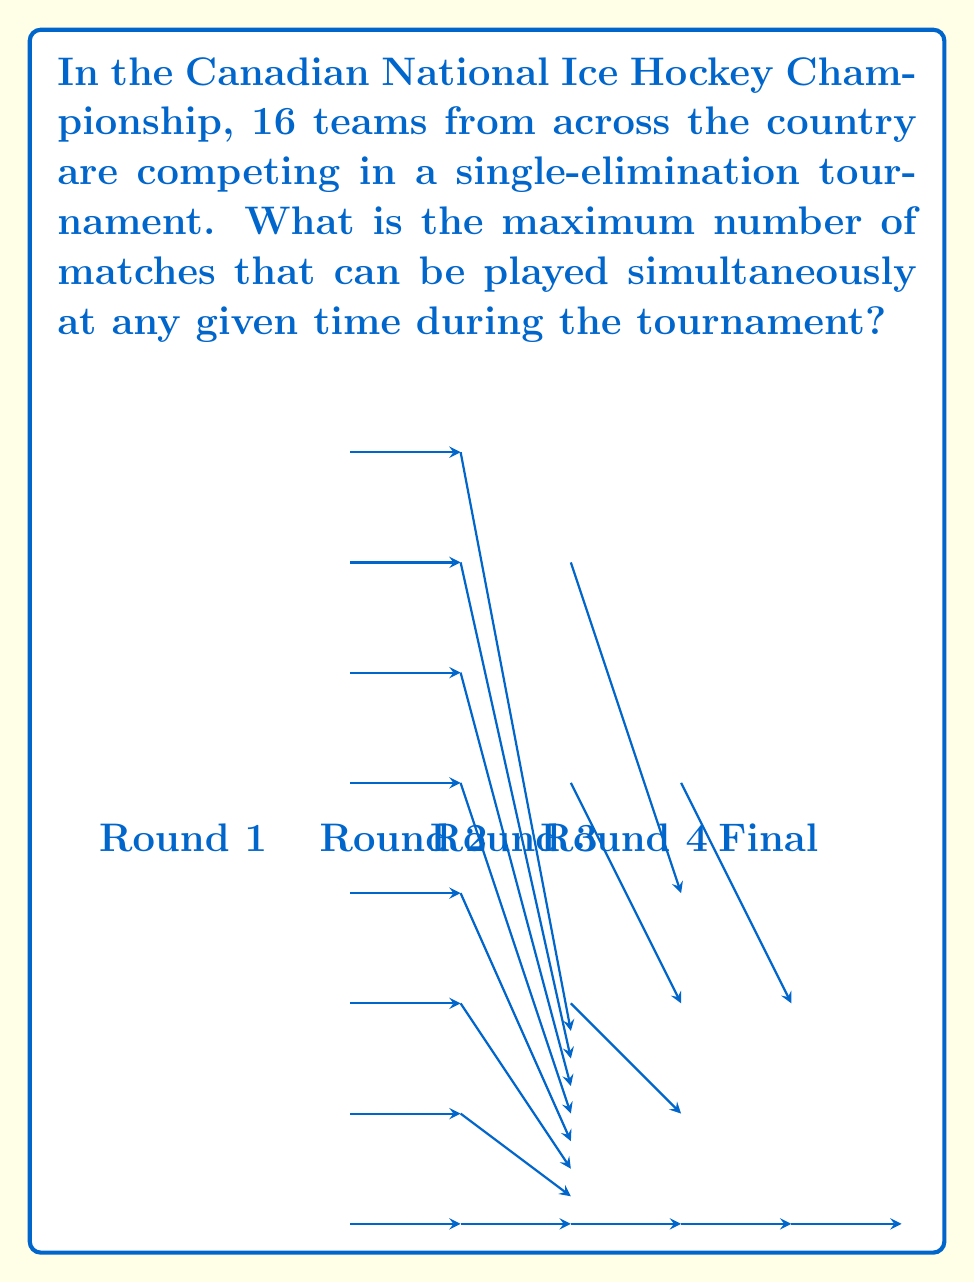Help me with this question. To solve this problem, we need to analyze the structure of a single-elimination tournament and determine the maximum number of matches that can occur simultaneously. Let's break it down step-by-step:

1) In a single-elimination tournament with 16 teams:
   - Round 1 (Round of 16): 8 matches
   - Round 2 (Quarter-finals): 4 matches
   - Round 3 (Semi-finals): 2 matches
   - Round 4 (Final): 1 match

2) The maximum number of simultaneous matches will occur in the round with the most matches, which is Round 1.

3) In Round 1, all 16 teams play, resulting in 8 matches.

4) These 8 matches can potentially be played simultaneously, as there are no dependencies between them.

5) In subsequent rounds, there will be fewer matches:
   - Round 2: 4 matches (can't start until Round 1 is complete)
   - Round 3: 2 matches (can't start until Round 2 is complete)
   - Round 4: 1 match (can't start until Round 3 is complete)

6) Therefore, the maximum number of simultaneous matches is 8, occurring in Round 1.

This tournament structure ensures that Canadian hockey fans can enjoy multiple exciting matches at the same time, showcasing the talent of teams from across the country.
Answer: 8 matches 